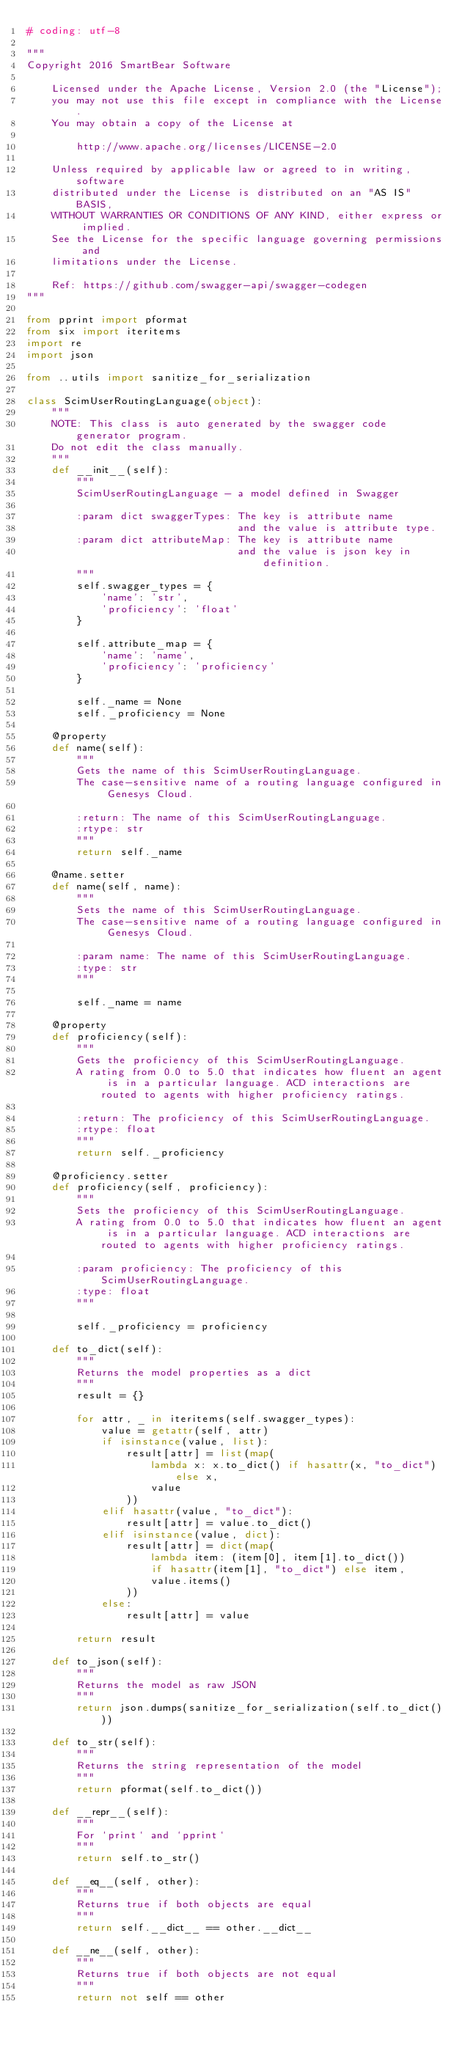<code> <loc_0><loc_0><loc_500><loc_500><_Python_># coding: utf-8

"""
Copyright 2016 SmartBear Software

    Licensed under the Apache License, Version 2.0 (the "License");
    you may not use this file except in compliance with the License.
    You may obtain a copy of the License at

        http://www.apache.org/licenses/LICENSE-2.0

    Unless required by applicable law or agreed to in writing, software
    distributed under the License is distributed on an "AS IS" BASIS,
    WITHOUT WARRANTIES OR CONDITIONS OF ANY KIND, either express or implied.
    See the License for the specific language governing permissions and
    limitations under the License.

    Ref: https://github.com/swagger-api/swagger-codegen
"""

from pprint import pformat
from six import iteritems
import re
import json

from ..utils import sanitize_for_serialization

class ScimUserRoutingLanguage(object):
    """
    NOTE: This class is auto generated by the swagger code generator program.
    Do not edit the class manually.
    """
    def __init__(self):
        """
        ScimUserRoutingLanguage - a model defined in Swagger

        :param dict swaggerTypes: The key is attribute name
                                  and the value is attribute type.
        :param dict attributeMap: The key is attribute name
                                  and the value is json key in definition.
        """
        self.swagger_types = {
            'name': 'str',
            'proficiency': 'float'
        }

        self.attribute_map = {
            'name': 'name',
            'proficiency': 'proficiency'
        }

        self._name = None
        self._proficiency = None

    @property
    def name(self):
        """
        Gets the name of this ScimUserRoutingLanguage.
        The case-sensitive name of a routing language configured in Genesys Cloud.

        :return: The name of this ScimUserRoutingLanguage.
        :rtype: str
        """
        return self._name

    @name.setter
    def name(self, name):
        """
        Sets the name of this ScimUserRoutingLanguage.
        The case-sensitive name of a routing language configured in Genesys Cloud.

        :param name: The name of this ScimUserRoutingLanguage.
        :type: str
        """
        
        self._name = name

    @property
    def proficiency(self):
        """
        Gets the proficiency of this ScimUserRoutingLanguage.
        A rating from 0.0 to 5.0 that indicates how fluent an agent is in a particular language. ACD interactions are routed to agents with higher proficiency ratings.

        :return: The proficiency of this ScimUserRoutingLanguage.
        :rtype: float
        """
        return self._proficiency

    @proficiency.setter
    def proficiency(self, proficiency):
        """
        Sets the proficiency of this ScimUserRoutingLanguage.
        A rating from 0.0 to 5.0 that indicates how fluent an agent is in a particular language. ACD interactions are routed to agents with higher proficiency ratings.

        :param proficiency: The proficiency of this ScimUserRoutingLanguage.
        :type: float
        """
        
        self._proficiency = proficiency

    def to_dict(self):
        """
        Returns the model properties as a dict
        """
        result = {}

        for attr, _ in iteritems(self.swagger_types):
            value = getattr(self, attr)
            if isinstance(value, list):
                result[attr] = list(map(
                    lambda x: x.to_dict() if hasattr(x, "to_dict") else x,
                    value
                ))
            elif hasattr(value, "to_dict"):
                result[attr] = value.to_dict()
            elif isinstance(value, dict):
                result[attr] = dict(map(
                    lambda item: (item[0], item[1].to_dict())
                    if hasattr(item[1], "to_dict") else item,
                    value.items()
                ))
            else:
                result[attr] = value

        return result

    def to_json(self):
        """
        Returns the model as raw JSON
        """
        return json.dumps(sanitize_for_serialization(self.to_dict()))

    def to_str(self):
        """
        Returns the string representation of the model
        """
        return pformat(self.to_dict())

    def __repr__(self):
        """
        For `print` and `pprint`
        """
        return self.to_str()

    def __eq__(self, other):
        """
        Returns true if both objects are equal
        """
        return self.__dict__ == other.__dict__

    def __ne__(self, other):
        """
        Returns true if both objects are not equal
        """
        return not self == other

</code> 